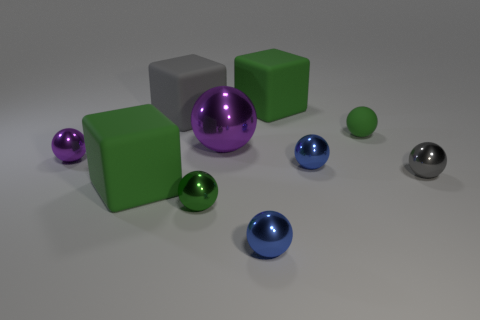Subtract 1 balls. How many balls are left? 6 Subtract all big balls. How many balls are left? 6 Subtract all purple balls. How many balls are left? 5 Subtract all yellow balls. Subtract all blue cubes. How many balls are left? 7 Subtract all spheres. How many objects are left? 3 Subtract 0 cyan spheres. How many objects are left? 10 Subtract all small cyan rubber things. Subtract all purple metal objects. How many objects are left? 8 Add 7 big blocks. How many big blocks are left? 10 Add 7 green matte objects. How many green matte objects exist? 10 